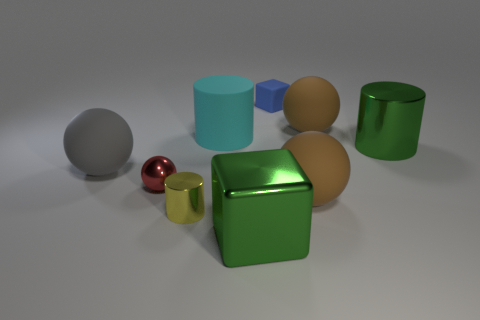Can you tell me the different colors present in these objects? Certainly! There are metallic shades of green and gold, a vibrant red, a solid blue, grey, and an off-white or cream color. 